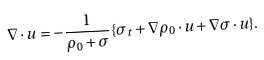<formula> <loc_0><loc_0><loc_500><loc_500>\nabla \cdot u = - \frac { 1 } { \rho _ { 0 } + \sigma } \{ \sigma _ { t } + \nabla \rho _ { 0 } \cdot u + \nabla \sigma \cdot u \} .</formula> 